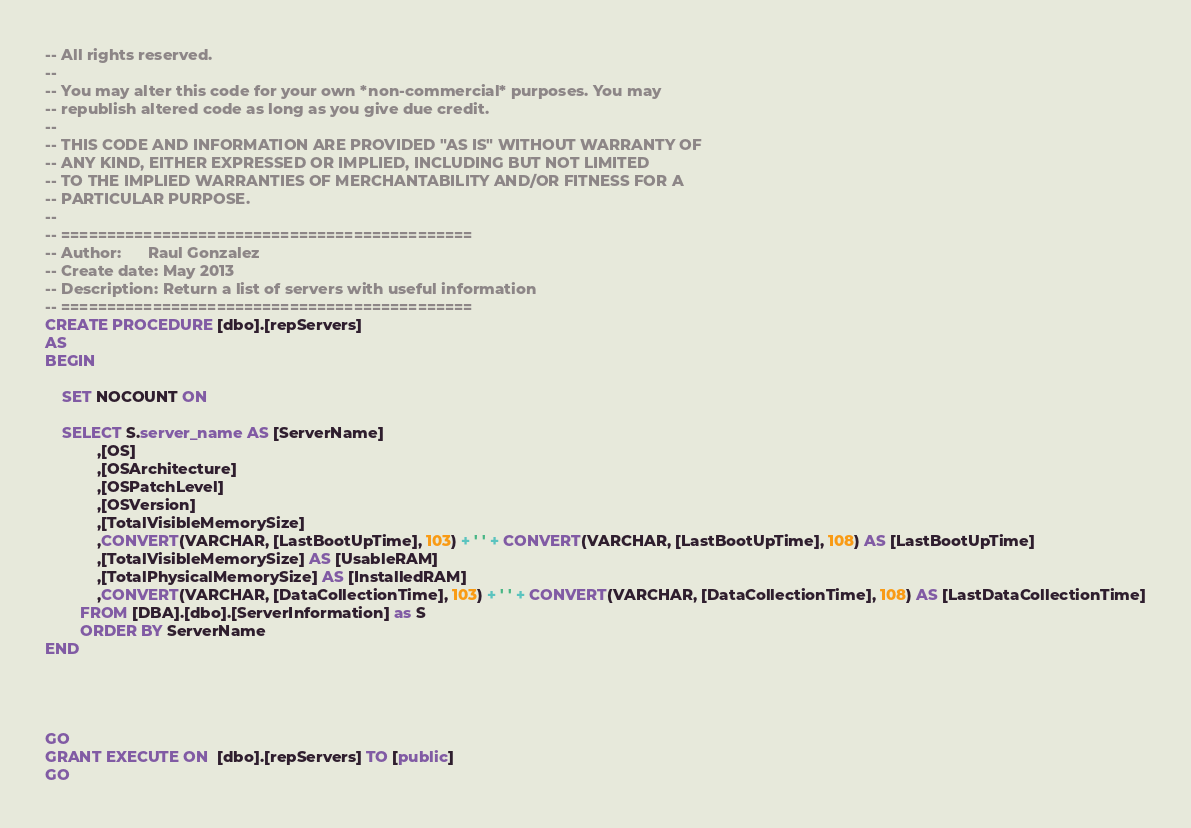Convert code to text. <code><loc_0><loc_0><loc_500><loc_500><_SQL_>-- All rights reserved.
--   
-- You may alter this code for your own *non-commercial* purposes. You may
-- republish altered code as long as you give due credit.
--   
-- THIS CODE AND INFORMATION ARE PROVIDED "AS IS" WITHOUT WARRANTY OF 
-- ANY KIND, EITHER EXPRESSED OR IMPLIED, INCLUDING BUT NOT LIMITED 
-- TO THE IMPLIED WARRANTIES OF MERCHANTABILITY AND/OR FITNESS FOR A
-- PARTICULAR PURPOSE.
--
-- =============================================
-- Author:		Raul Gonzalez
-- Create date: May 2013
-- Description:	Return a list of servers with useful information
-- =============================================
CREATE PROCEDURE [dbo].[repServers]
AS
BEGIN
	
	SET NOCOUNT ON

    SELECT S.server_name AS [ServerName]
			,[OS]
			,[OSArchitecture]
			,[OSPatchLevel]
			,[OSVersion]
			,[TotalVisibleMemorySize]
			,CONVERT(VARCHAR, [LastBootUpTime], 103) + ' ' + CONVERT(VARCHAR, [LastBootUpTime], 108) AS [LastBootUpTime]
			,[TotalVisibleMemorySize] AS [UsableRAM]
			,[TotalPhysicalMemorySize] AS [InstalledRAM]
			,CONVERT(VARCHAR, [DataCollectionTime], 103) + ' ' + CONVERT(VARCHAR, [DataCollectionTime], 108) AS [LastDataCollectionTime]
		FROM [DBA].[dbo].[ServerInformation] as S
		ORDER BY ServerName
END




GO
GRANT EXECUTE ON  [dbo].[repServers] TO [public]
GO
</code> 